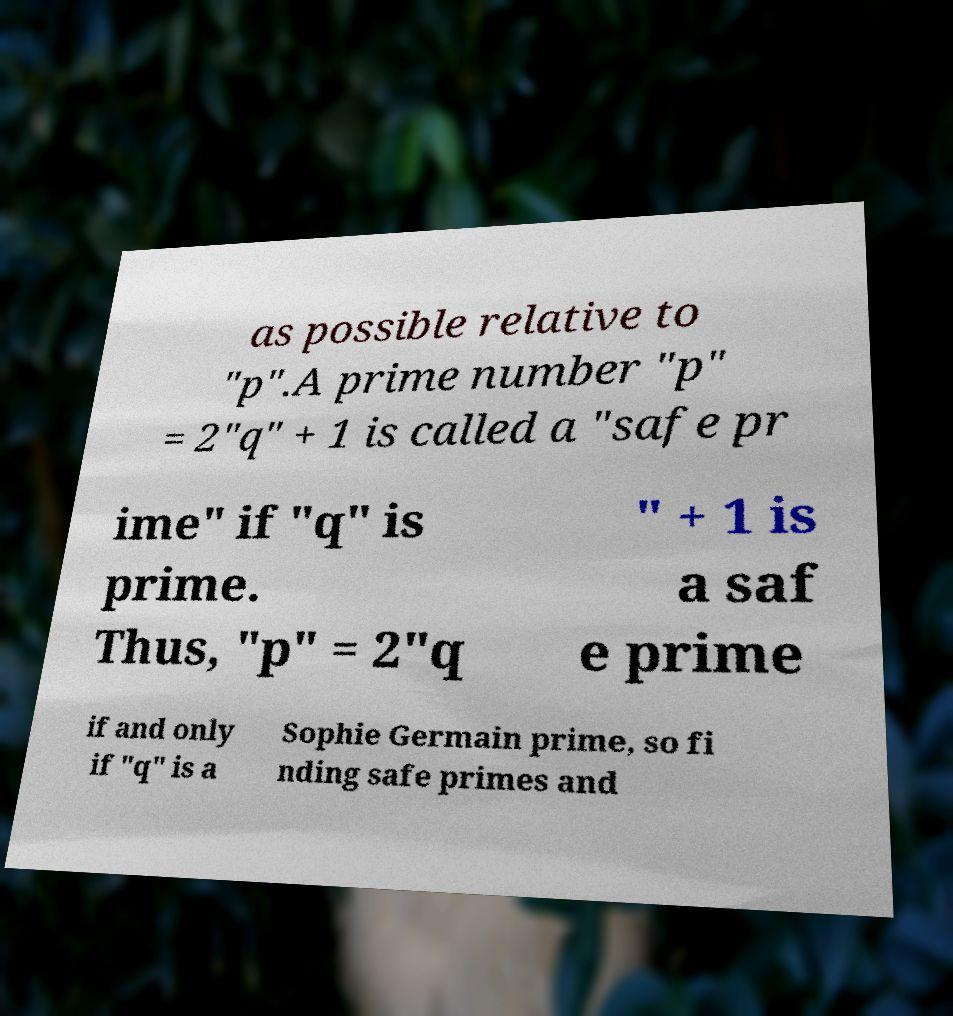For documentation purposes, I need the text within this image transcribed. Could you provide that? as possible relative to "p".A prime number "p" = 2"q" + 1 is called a "safe pr ime" if "q" is prime. Thus, "p" = 2"q " + 1 is a saf e prime if and only if "q" is a Sophie Germain prime, so fi nding safe primes and 